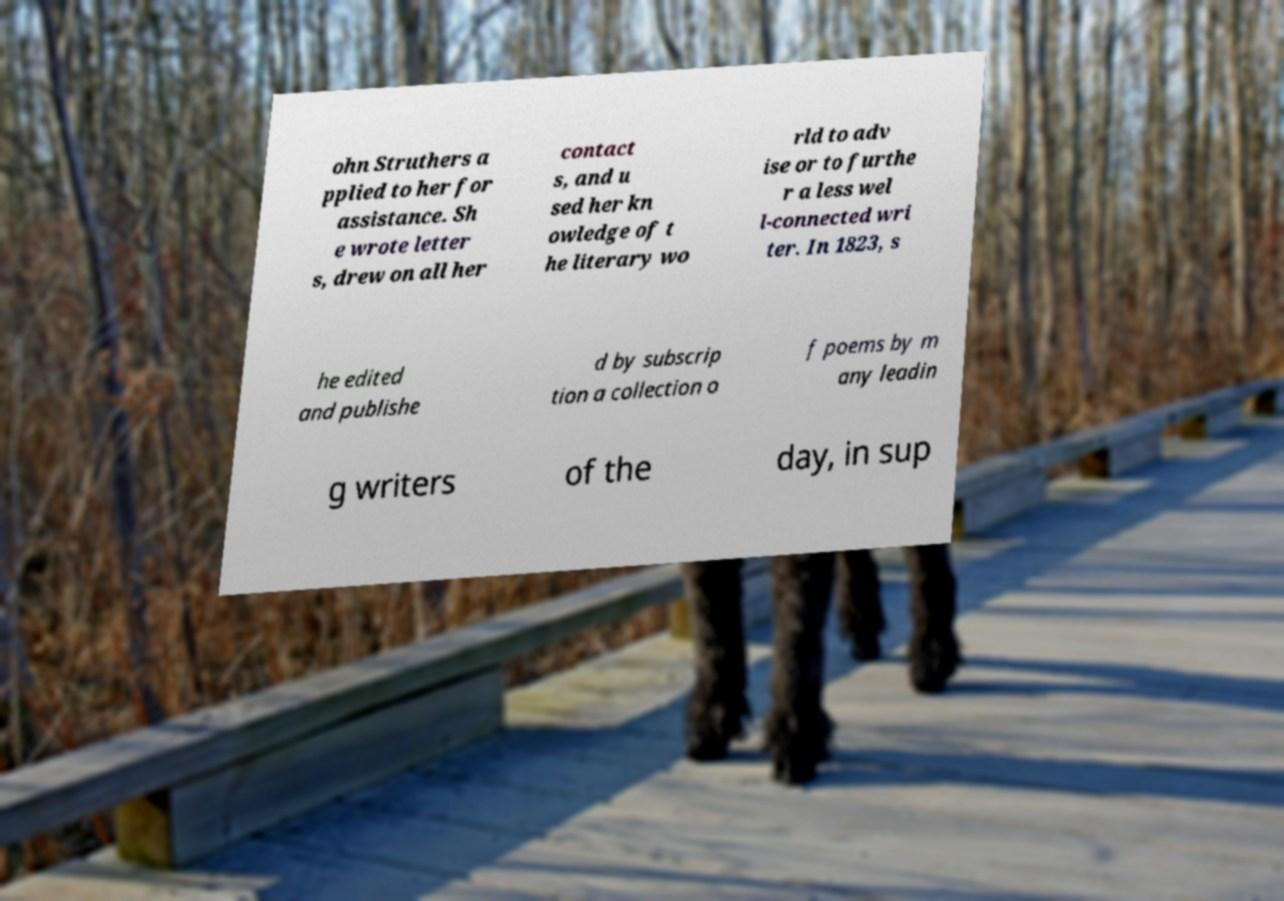Can you read and provide the text displayed in the image?This photo seems to have some interesting text. Can you extract and type it out for me? ohn Struthers a pplied to her for assistance. Sh e wrote letter s, drew on all her contact s, and u sed her kn owledge of t he literary wo rld to adv ise or to furthe r a less wel l-connected wri ter. In 1823, s he edited and publishe d by subscrip tion a collection o f poems by m any leadin g writers of the day, in sup 